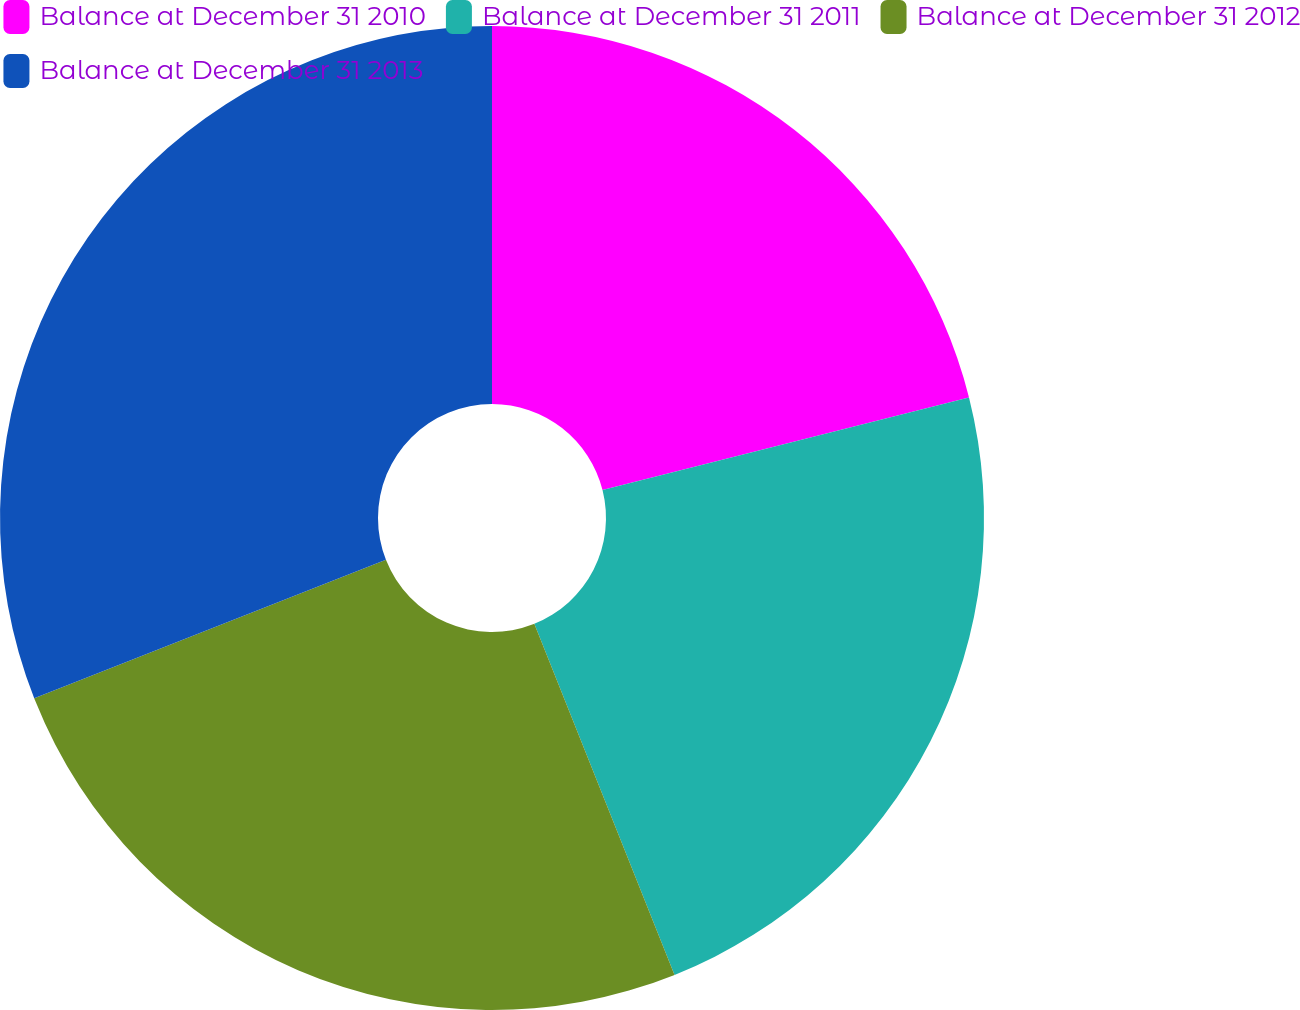Convert chart to OTSL. <chart><loc_0><loc_0><loc_500><loc_500><pie_chart><fcel>Balance at December 31 2010<fcel>Balance at December 31 2011<fcel>Balance at December 31 2012<fcel>Balance at December 31 2013<nl><fcel>21.06%<fcel>22.89%<fcel>25.08%<fcel>30.97%<nl></chart> 